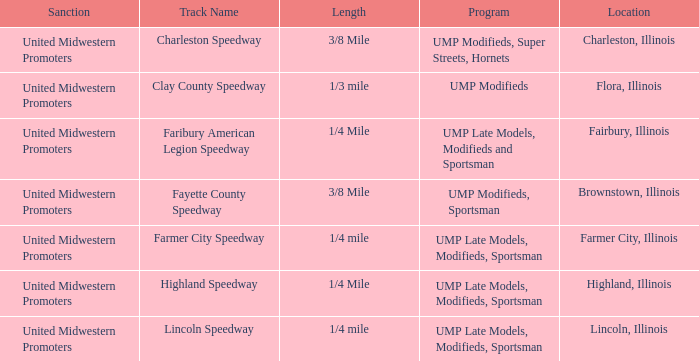Who sanctioned the event at fayette county speedway? United Midwestern Promoters. 